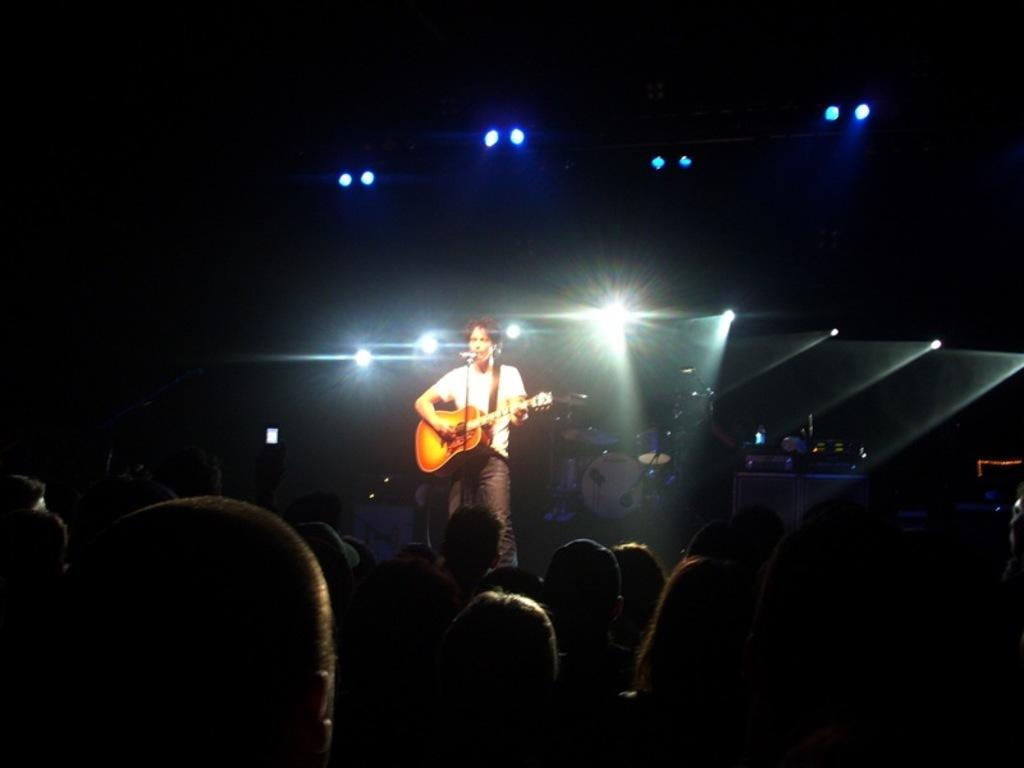What is the person in the image doing? The person is playing a guitar and singing. What is the person wearing? The person is wearing a white shirt. What musical instrument is visible behind the person? There are drums behind the person. What object is in front of the person? There is a microphone in front of the person. Who are the people in front of the person? There is a group of people in front of the person. What is the name of the mint that the person is holding in the image? There is no mint present in the image; the person is playing a guitar and singing. 